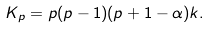<formula> <loc_0><loc_0><loc_500><loc_500>K _ { p } = p ( p - 1 ) ( p + 1 - \alpha ) k .</formula> 